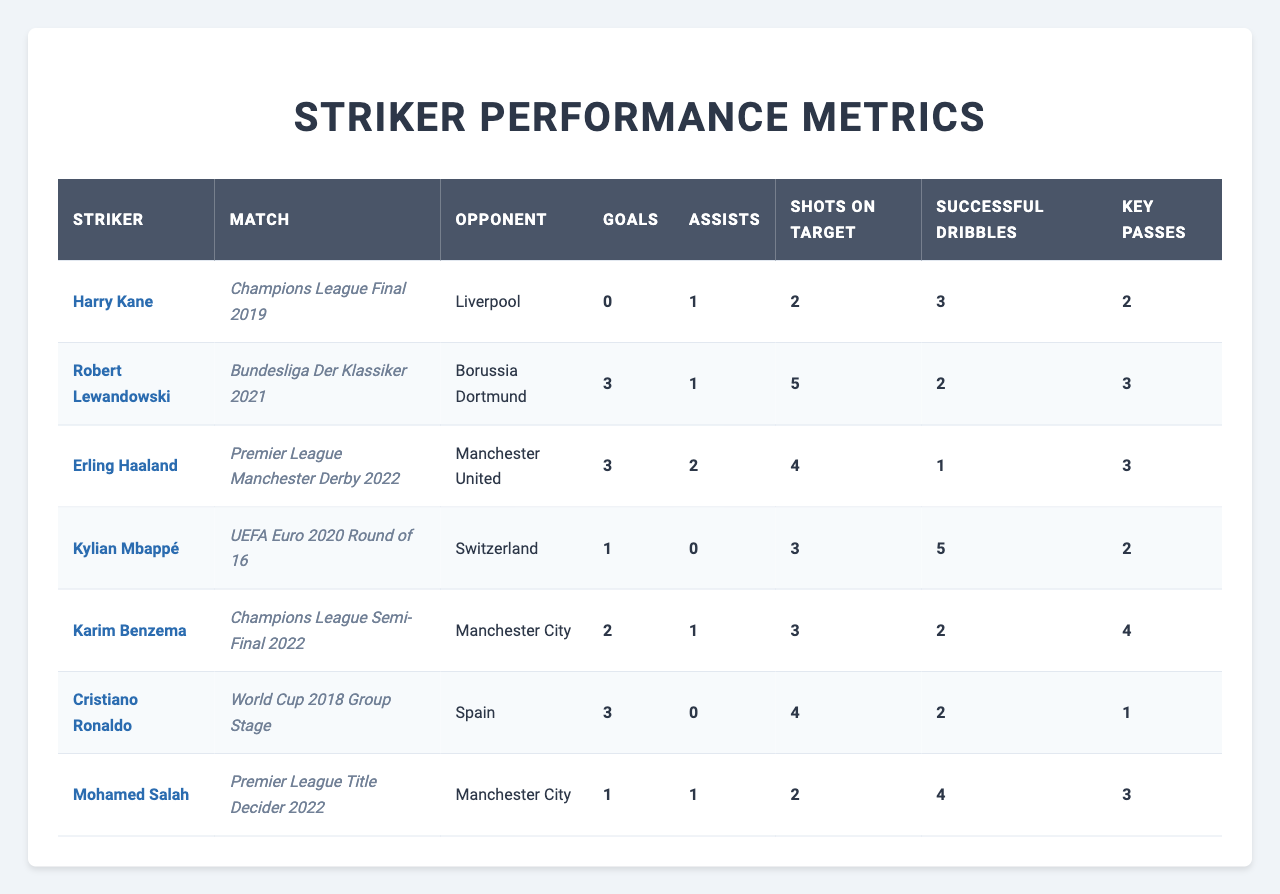What striker scored the most goals in the table? By examining the "Goals" column for each striker, we see Robert Lewandowski and Cristiano Ronaldo both scored 3 goals, which is the highest among all entries.
Answer: Robert Lewandowski and Cristiano Ronaldo Which match did Kylian Mbappé play against Switzerland? The table mentions "UEFA Euro 2020 Round of 16" under the "Match" column next to Kylian Mbappé's name.
Answer: UEFA Euro 2020 Round of 16 Did Harry Kane score any goals in the Champions League Final 2019? According to the "Goals" column for Harry Kane, it clearly shows 0 goals scored, indicating he did not score any.
Answer: No Who had the highest number of assists in a match? By checking the "Assists" column, we find that Erling Haaland and Karim Benzema both had 2 assists, while Robert Lewandowski, Kylian Mbappé, and Mohamed Salah had fewer. Therefore, the highest is 2 assists.
Answer: Erling Haaland and Karim Benzema What is the total number of shots on target by all strikers in the matches listed? Summing the "Shots on Target" column: 2 + 5 + 4 + 3 + 3 + 4 + 2 = 23.
Answer: 23 Did any striker provide more key passes than the goals scored in their respective match? By analyzing the "Key Passes" and "Goals" columns, we find that Harry Kane had 2 key passes with 0 goals, and Mohamed Salah had 3 key passes with 1 goal, indicating both provided more key passes than they scored.
Answer: Yes In which match did the striker with the most successful dribbles play? Kylian Mbappé recorded the highest successful dribbles, which is 5, in the match against Switzerland.
Answer: UEFA Euro 2020 Round of 16 Which player had the highest combination of goals and assists in their match? Adding the goals and assists for each player: Lewandowski (3+1=4), Haaland (3+2=5), Benzema (2+1=3), Ronaldo (3+0=3), Salah (1+1=2), Kane (0+1=1), and Mbappé (1+0=1). The maximum is 5 by Erling Haaland.
Answer: Erling Haaland Is it true that all strikers in the table had a successful dribble count of at least 1? Reviewing the "Successful Dribbles" column reveals that Haaland recorded only 1 successful dribble, making it false that all had at least 1 successful dribble.
Answer: No 